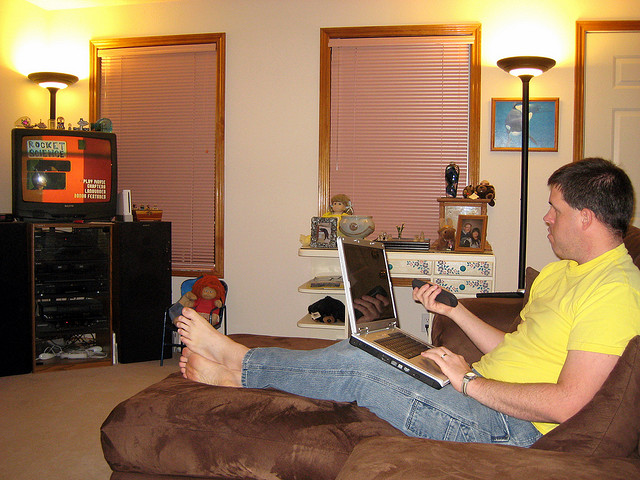How many young elephants are shown? 0 